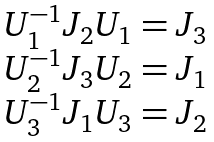Convert formula to latex. <formula><loc_0><loc_0><loc_500><loc_500>\begin{array} { c } { { U _ { 1 } ^ { - 1 } J _ { 2 } U _ { 1 } = J _ { 3 } } } \\ { { U _ { 2 } ^ { - 1 } J _ { 3 } U _ { 2 } = J _ { 1 } } } \\ { { U _ { 3 } ^ { - 1 } J _ { 1 } U _ { 3 } = J _ { 2 } } } \end{array}</formula> 